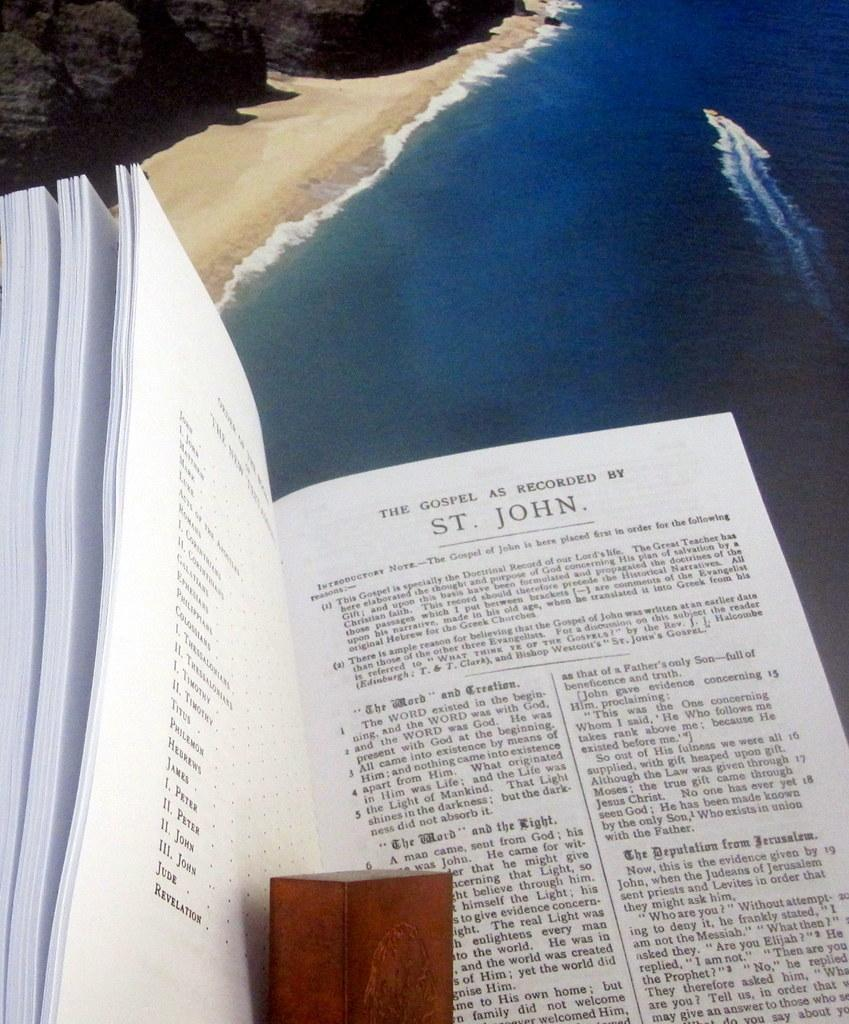<image>
Give a short and clear explanation of the subsequent image. A bible is open to the gospel of St. John. 